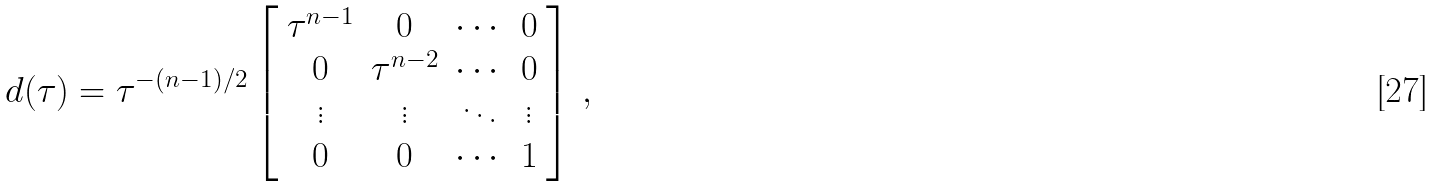Convert formula to latex. <formula><loc_0><loc_0><loc_500><loc_500>d ( \tau ) = \tau ^ { - ( n - 1 ) / 2 } \left [ \begin{array} { c c c c } \tau ^ { n - 1 } & 0 & \cdots & 0 \\ 0 & \tau ^ { n - 2 } & \cdots & 0 \\ \vdots & \vdots & \ddots & \vdots \\ 0 & 0 & \cdots & 1 \end{array} \right ] \, ,</formula> 